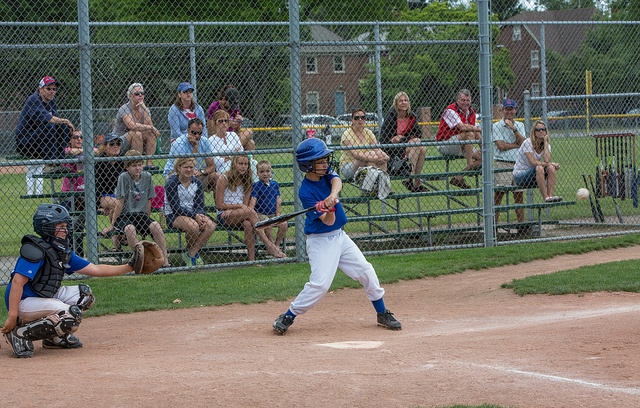Describe the objects in this image and their specific colors. I can see people in black, gray, and darkgray tones, people in black, gray, and navy tones, people in black, lightgray, navy, and darkgray tones, people in black, gray, navy, and blue tones, and people in black, gray, and maroon tones in this image. 